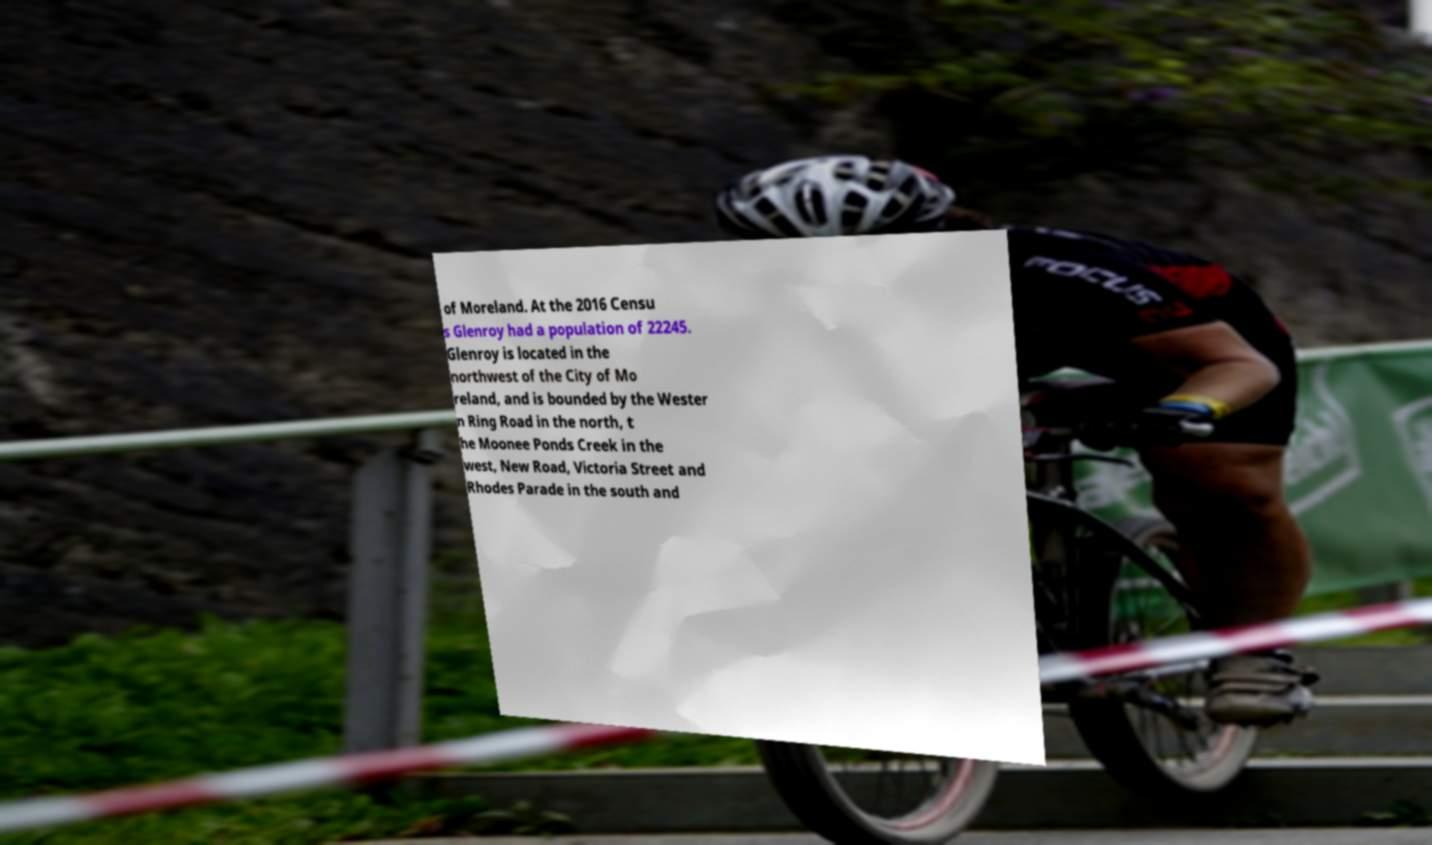What messages or text are displayed in this image? I need them in a readable, typed format. of Moreland. At the 2016 Censu s Glenroy had a population of 22245. Glenroy is located in the northwest of the City of Mo reland, and is bounded by the Wester n Ring Road in the north, t he Moonee Ponds Creek in the west, New Road, Victoria Street and Rhodes Parade in the south and 